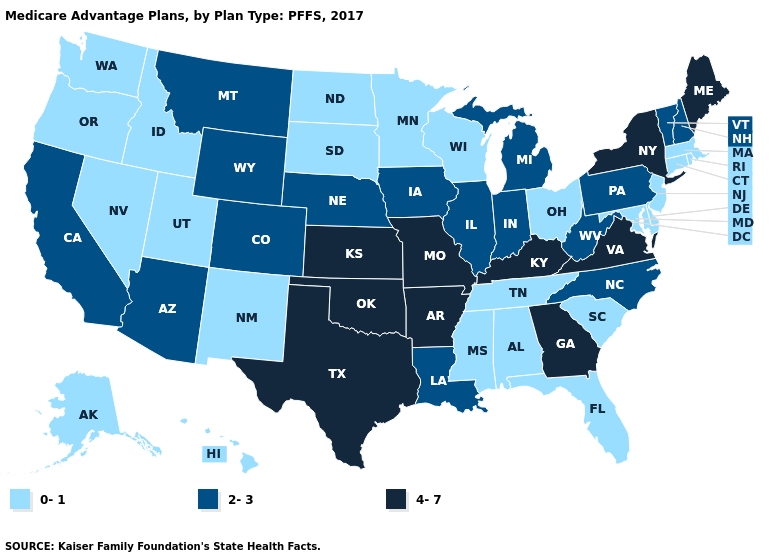Which states have the highest value in the USA?
Answer briefly. Arkansas, Georgia, Kansas, Kentucky, Maine, Missouri, New York, Oklahoma, Texas, Virginia. Name the states that have a value in the range 0-1?
Write a very short answer. Alaska, Alabama, Connecticut, Delaware, Florida, Hawaii, Idaho, Massachusetts, Maryland, Minnesota, Mississippi, North Dakota, New Jersey, New Mexico, Nevada, Ohio, Oregon, Rhode Island, South Carolina, South Dakota, Tennessee, Utah, Washington, Wisconsin. Does Delaware have the highest value in the South?
Concise answer only. No. Among the states that border West Virginia , does Ohio have the highest value?
Short answer required. No. Is the legend a continuous bar?
Quick response, please. No. Does Massachusetts have the lowest value in the Northeast?
Write a very short answer. Yes. Name the states that have a value in the range 0-1?
Write a very short answer. Alaska, Alabama, Connecticut, Delaware, Florida, Hawaii, Idaho, Massachusetts, Maryland, Minnesota, Mississippi, North Dakota, New Jersey, New Mexico, Nevada, Ohio, Oregon, Rhode Island, South Carolina, South Dakota, Tennessee, Utah, Washington, Wisconsin. Does the first symbol in the legend represent the smallest category?
Be succinct. Yes. Which states have the lowest value in the Northeast?
Short answer required. Connecticut, Massachusetts, New Jersey, Rhode Island. Does Connecticut have the highest value in the USA?
Give a very brief answer. No. Is the legend a continuous bar?
Short answer required. No. Among the states that border North Dakota , which have the lowest value?
Write a very short answer. Minnesota, South Dakota. Which states have the lowest value in the USA?
Short answer required. Alaska, Alabama, Connecticut, Delaware, Florida, Hawaii, Idaho, Massachusetts, Maryland, Minnesota, Mississippi, North Dakota, New Jersey, New Mexico, Nevada, Ohio, Oregon, Rhode Island, South Carolina, South Dakota, Tennessee, Utah, Washington, Wisconsin. Does the first symbol in the legend represent the smallest category?
Keep it brief. Yes. Name the states that have a value in the range 0-1?
Answer briefly. Alaska, Alabama, Connecticut, Delaware, Florida, Hawaii, Idaho, Massachusetts, Maryland, Minnesota, Mississippi, North Dakota, New Jersey, New Mexico, Nevada, Ohio, Oregon, Rhode Island, South Carolina, South Dakota, Tennessee, Utah, Washington, Wisconsin. 